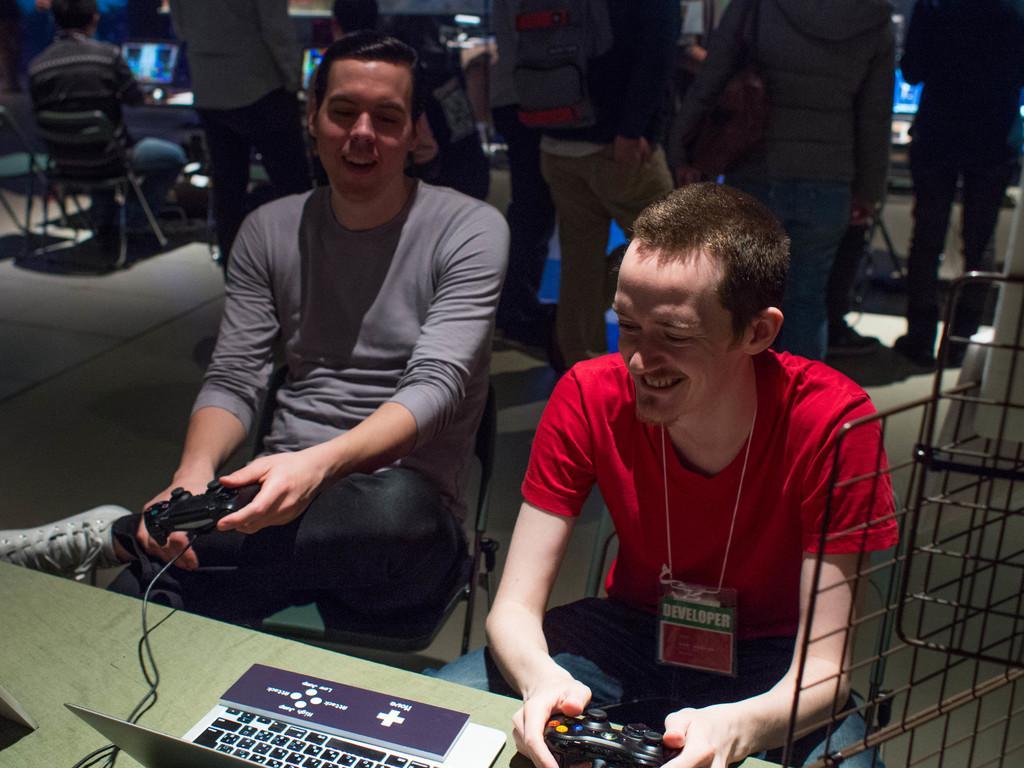Describe this image in one or two sentences. In the image there are two men in grey and red t-shirt sitting in front of table holding joy sticks and laptop on the table, behind there are few people standing, on the left side background there is another man sitting in front of table with laptop on it. 